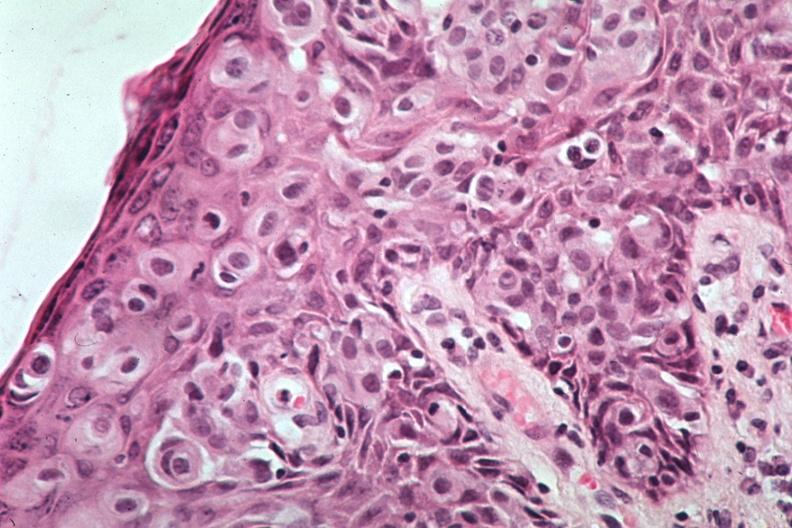s breast present?
Answer the question using a single word or phrase. Yes 